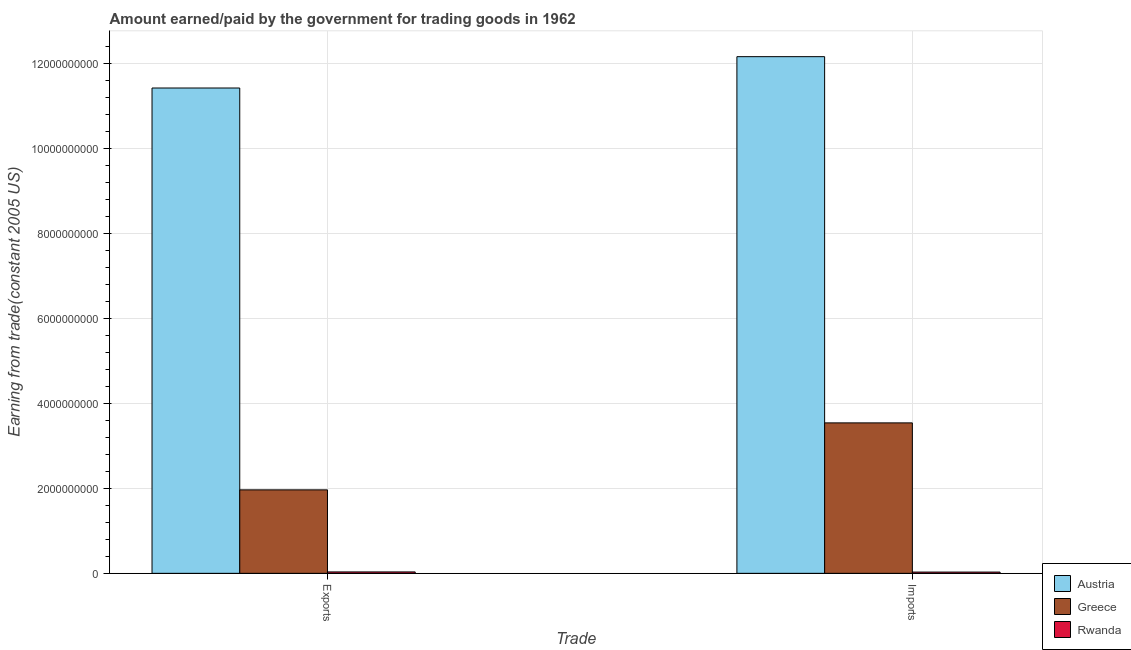How many different coloured bars are there?
Provide a short and direct response. 3. How many groups of bars are there?
Provide a succinct answer. 2. How many bars are there on the 1st tick from the right?
Your response must be concise. 3. What is the label of the 2nd group of bars from the left?
Give a very brief answer. Imports. What is the amount earned from exports in Austria?
Your answer should be compact. 1.14e+1. Across all countries, what is the maximum amount earned from exports?
Provide a short and direct response. 1.14e+1. Across all countries, what is the minimum amount paid for imports?
Keep it short and to the point. 2.97e+07. In which country was the amount paid for imports minimum?
Give a very brief answer. Rwanda. What is the total amount paid for imports in the graph?
Provide a succinct answer. 1.57e+1. What is the difference between the amount earned from exports in Austria and that in Greece?
Offer a terse response. 9.46e+09. What is the difference between the amount earned from exports in Austria and the amount paid for imports in Rwanda?
Give a very brief answer. 1.14e+1. What is the average amount paid for imports per country?
Provide a succinct answer. 5.25e+09. What is the difference between the amount paid for imports and amount earned from exports in Austria?
Your answer should be compact. 7.38e+08. What is the ratio of the amount earned from exports in Rwanda to that in Austria?
Offer a very short reply. 0. In how many countries, is the amount paid for imports greater than the average amount paid for imports taken over all countries?
Your response must be concise. 1. How many countries are there in the graph?
Keep it short and to the point. 3. Does the graph contain any zero values?
Keep it short and to the point. No. How many legend labels are there?
Give a very brief answer. 3. How are the legend labels stacked?
Offer a terse response. Vertical. What is the title of the graph?
Provide a succinct answer. Amount earned/paid by the government for trading goods in 1962. What is the label or title of the X-axis?
Your response must be concise. Trade. What is the label or title of the Y-axis?
Provide a succinct answer. Earning from trade(constant 2005 US). What is the Earning from trade(constant 2005 US) of Austria in Exports?
Provide a succinct answer. 1.14e+1. What is the Earning from trade(constant 2005 US) in Greece in Exports?
Provide a short and direct response. 1.97e+09. What is the Earning from trade(constant 2005 US) in Rwanda in Exports?
Offer a very short reply. 3.32e+07. What is the Earning from trade(constant 2005 US) in Austria in Imports?
Keep it short and to the point. 1.22e+1. What is the Earning from trade(constant 2005 US) of Greece in Imports?
Your response must be concise. 3.54e+09. What is the Earning from trade(constant 2005 US) in Rwanda in Imports?
Provide a short and direct response. 2.97e+07. Across all Trade, what is the maximum Earning from trade(constant 2005 US) of Austria?
Give a very brief answer. 1.22e+1. Across all Trade, what is the maximum Earning from trade(constant 2005 US) in Greece?
Make the answer very short. 3.54e+09. Across all Trade, what is the maximum Earning from trade(constant 2005 US) in Rwanda?
Ensure brevity in your answer.  3.32e+07. Across all Trade, what is the minimum Earning from trade(constant 2005 US) in Austria?
Provide a succinct answer. 1.14e+1. Across all Trade, what is the minimum Earning from trade(constant 2005 US) in Greece?
Offer a very short reply. 1.97e+09. Across all Trade, what is the minimum Earning from trade(constant 2005 US) in Rwanda?
Your response must be concise. 2.97e+07. What is the total Earning from trade(constant 2005 US) of Austria in the graph?
Make the answer very short. 2.36e+1. What is the total Earning from trade(constant 2005 US) of Greece in the graph?
Make the answer very short. 5.51e+09. What is the total Earning from trade(constant 2005 US) in Rwanda in the graph?
Make the answer very short. 6.29e+07. What is the difference between the Earning from trade(constant 2005 US) in Austria in Exports and that in Imports?
Keep it short and to the point. -7.38e+08. What is the difference between the Earning from trade(constant 2005 US) in Greece in Exports and that in Imports?
Ensure brevity in your answer.  -1.58e+09. What is the difference between the Earning from trade(constant 2005 US) of Rwanda in Exports and that in Imports?
Give a very brief answer. 3.50e+06. What is the difference between the Earning from trade(constant 2005 US) of Austria in Exports and the Earning from trade(constant 2005 US) of Greece in Imports?
Offer a terse response. 7.89e+09. What is the difference between the Earning from trade(constant 2005 US) in Austria in Exports and the Earning from trade(constant 2005 US) in Rwanda in Imports?
Make the answer very short. 1.14e+1. What is the difference between the Earning from trade(constant 2005 US) in Greece in Exports and the Earning from trade(constant 2005 US) in Rwanda in Imports?
Offer a terse response. 1.94e+09. What is the average Earning from trade(constant 2005 US) in Austria per Trade?
Your answer should be very brief. 1.18e+1. What is the average Earning from trade(constant 2005 US) in Greece per Trade?
Ensure brevity in your answer.  2.75e+09. What is the average Earning from trade(constant 2005 US) of Rwanda per Trade?
Make the answer very short. 3.15e+07. What is the difference between the Earning from trade(constant 2005 US) in Austria and Earning from trade(constant 2005 US) in Greece in Exports?
Ensure brevity in your answer.  9.46e+09. What is the difference between the Earning from trade(constant 2005 US) of Austria and Earning from trade(constant 2005 US) of Rwanda in Exports?
Provide a short and direct response. 1.14e+1. What is the difference between the Earning from trade(constant 2005 US) of Greece and Earning from trade(constant 2005 US) of Rwanda in Exports?
Give a very brief answer. 1.93e+09. What is the difference between the Earning from trade(constant 2005 US) in Austria and Earning from trade(constant 2005 US) in Greece in Imports?
Your answer should be compact. 8.62e+09. What is the difference between the Earning from trade(constant 2005 US) of Austria and Earning from trade(constant 2005 US) of Rwanda in Imports?
Offer a terse response. 1.21e+1. What is the difference between the Earning from trade(constant 2005 US) in Greece and Earning from trade(constant 2005 US) in Rwanda in Imports?
Ensure brevity in your answer.  3.51e+09. What is the ratio of the Earning from trade(constant 2005 US) in Austria in Exports to that in Imports?
Your response must be concise. 0.94. What is the ratio of the Earning from trade(constant 2005 US) in Greece in Exports to that in Imports?
Give a very brief answer. 0.55. What is the ratio of the Earning from trade(constant 2005 US) in Rwanda in Exports to that in Imports?
Provide a short and direct response. 1.12. What is the difference between the highest and the second highest Earning from trade(constant 2005 US) in Austria?
Your answer should be compact. 7.38e+08. What is the difference between the highest and the second highest Earning from trade(constant 2005 US) in Greece?
Offer a very short reply. 1.58e+09. What is the difference between the highest and the second highest Earning from trade(constant 2005 US) of Rwanda?
Your answer should be very brief. 3.50e+06. What is the difference between the highest and the lowest Earning from trade(constant 2005 US) of Austria?
Offer a terse response. 7.38e+08. What is the difference between the highest and the lowest Earning from trade(constant 2005 US) of Greece?
Provide a short and direct response. 1.58e+09. What is the difference between the highest and the lowest Earning from trade(constant 2005 US) of Rwanda?
Ensure brevity in your answer.  3.50e+06. 